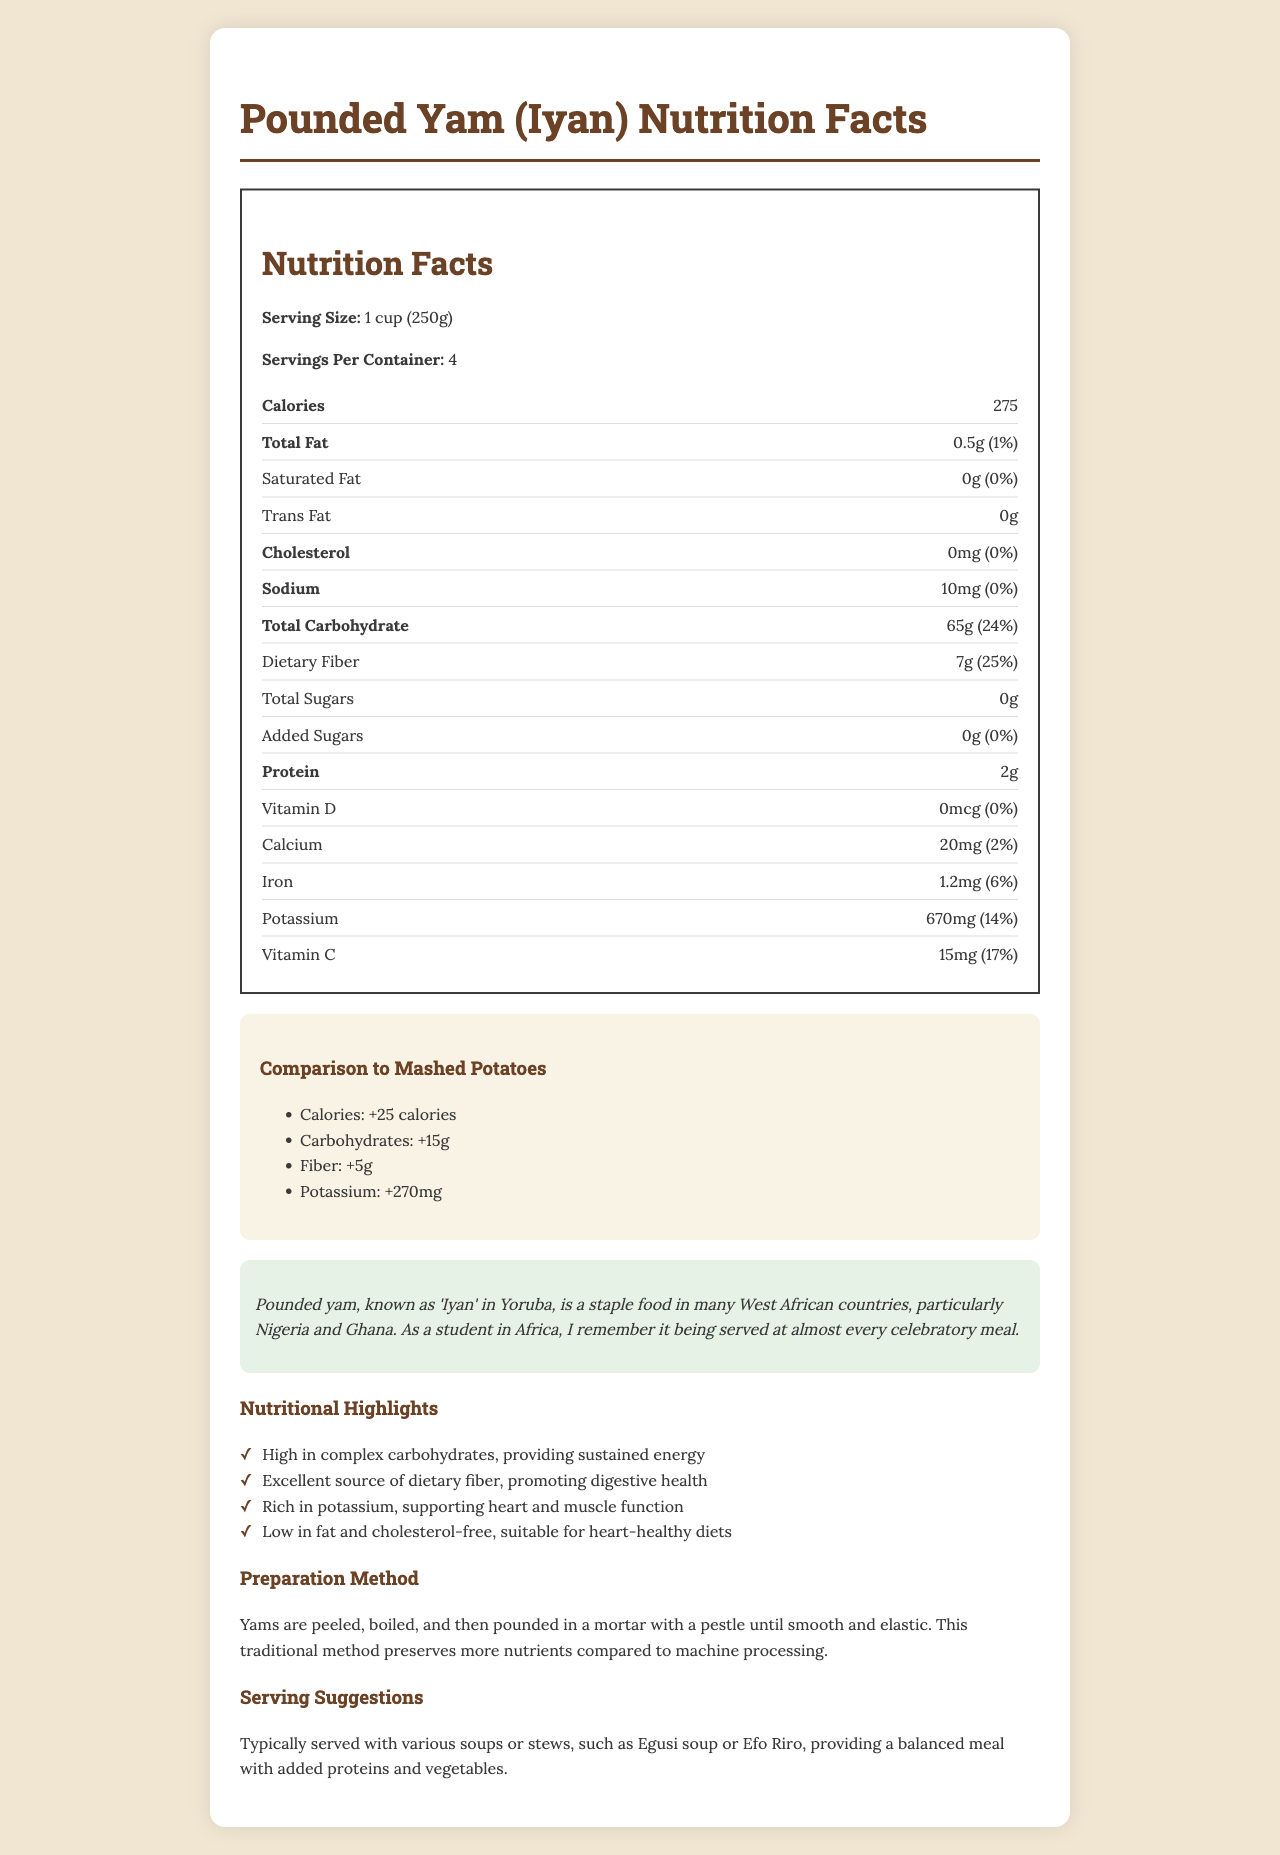what is the serving size for Pounded Yam? The serving size is explicitly stated as "1 cup (250g)" in the document.
Answer: 1 cup (250g) how much sodium is in one serving of Pounded Yam? The document indicates that there are 10mg of sodium in one serving.
Answer: 10mg what percent daily value of dietary fiber is in one serving of Pounded Yam? According to the nutrition facts in the document, the dietary fiber is 7g, which is 25% of the daily value.
Answer: 25% how many servings are there per container? The document states that each container has 4 servings.
Answer: 4 how is Pounded Yam traditionally prepared? The preparation method is detailed in the document, stating that yams are peeled, boiled, and then pounded in a mortar with a pestle until smooth and elastic.
Answer: Peeled, boiled, and pounded in a mortar with a pestle until smooth and elastic compare the potassium content: Pounded Yam vs. Mashed Potatoes. The document states that Pounded Yam has 670mg of potassium and the comparison section indicates a difference of +270mg over Mashed Potatoes.
Answer: Pounded Yam contains 270mg more potassium than Mashed Potatoes. which nutrient is most abundant in Pounded Yam? A. Fat B. Protein C. Carbohydrate D. Fiber The document shows that carbohydrates are the most abundant nutrient with 65g per serving.
Answer: C which vitamin has no contribution to the daily value in Pounded Yam? A. Vitamin D B. Vitamin C C. Calcium D. Iron Vitamin D has 0mcg and contributes 0% to the daily value according to the document.
Answer: A is Pounded Yam high in cholesterol? The document clearly states that Pounded Yam has 0mg of cholesterol, which is 0% of the daily value.
Answer: No does Pounded Yam contain any added sugars? The document mentions that there are 0g of added sugars in Pounded Yam.
Answer: No summarize the nutrition facts and cultural context of Pounded Yam. The document provides detailed nutritional information, cultural context, and traditional preparation methods, emphasizing its nutritional benefits and cultural significance.
Answer: Pounded Yam (Iyan) is a traditional African dish high in carbohydrates and fiber, low in fat, and free of cholesterol. It is a staple in West African countries, particularly Nigeria and Ghana, often served during celebrations. how does Pounded Yam support heart health? The document highlights that Pounded Yam is high in dietary fiber, rich in potassium, and low in fat, with 0% cholesterol, which are beneficial for heart health.
Answer: High in dietary fiber, rich in potassium, low in fat, and cholesterol-free what are some serving suggestions for Pounded Yam? The document suggests serving Pounded Yam with soups or stews like Egusi soup or Efo Riro.
Answer: Typically served with various soups or stews, such as Egusi soup or Efo Riro what is the difference in carbohydrate content between Pounded Yam and Mashed Potatoes? The comparison section states that Pounded Yam has 15g more carbohydrates than Mashed Potatoes.
Answer: Pounded Yam has 15g more carbohydrates than Mashed Potatoes. what other dish is compared with Pounded Yam? how much more calories does Pounded Yam contain than it? The document compares Pounded Yam to Mashed Potatoes and indicates that Pounded Yam has 25 more calories.
Answer: Mashed Potatoes; Pounded Yam contains 25 more calories do the nutritional facts contain information about the cooking time for Pounded Yam? The document does not provide details about the cooking time for Pounded Yam.
Answer: Not enough information 